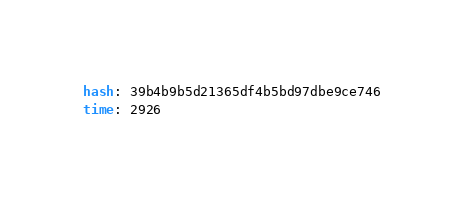<code> <loc_0><loc_0><loc_500><loc_500><_YAML_>hash: 39b4b9b5d21365df4b5bd97dbe9ce746
time: 2926
</code> 